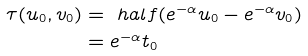<formula> <loc_0><loc_0><loc_500><loc_500>\tau ( u _ { 0 } , v _ { 0 } ) & = \ h a l f ( e ^ { - \alpha } u _ { 0 } - e ^ { - \alpha } v _ { 0 } ) \\ & = e ^ { - \alpha } t _ { 0 }</formula> 